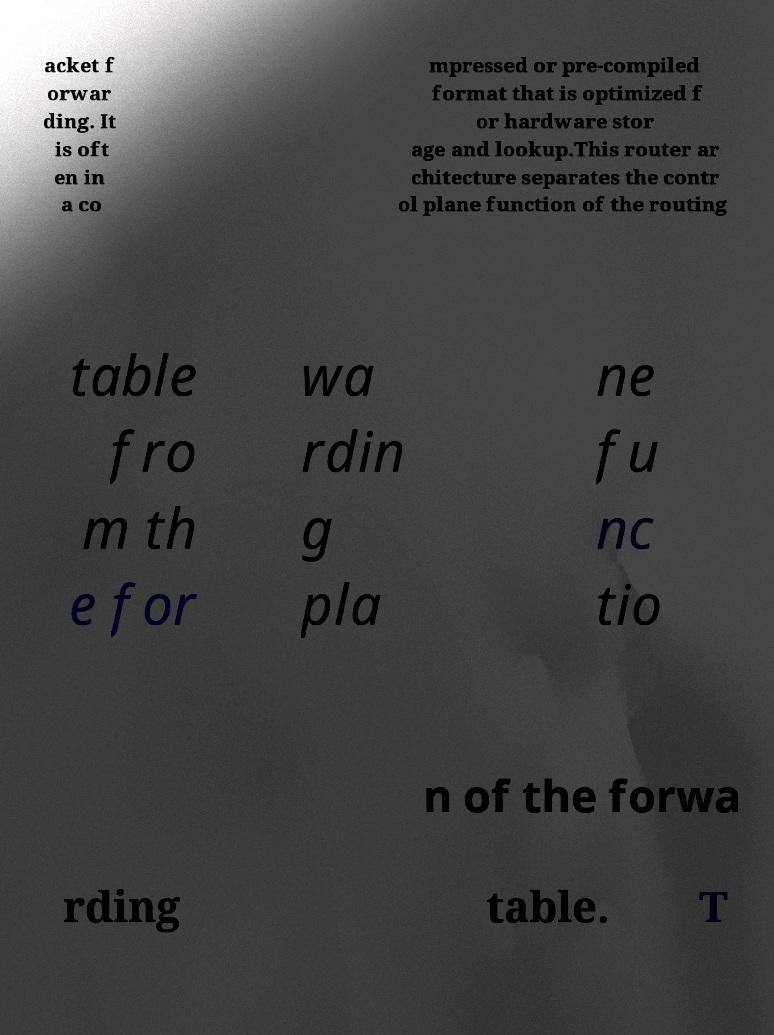Can you read and provide the text displayed in the image?This photo seems to have some interesting text. Can you extract and type it out for me? acket f orwar ding. It is oft en in a co mpressed or pre-compiled format that is optimized f or hardware stor age and lookup.This router ar chitecture separates the contr ol plane function of the routing table fro m th e for wa rdin g pla ne fu nc tio n of the forwa rding table. T 